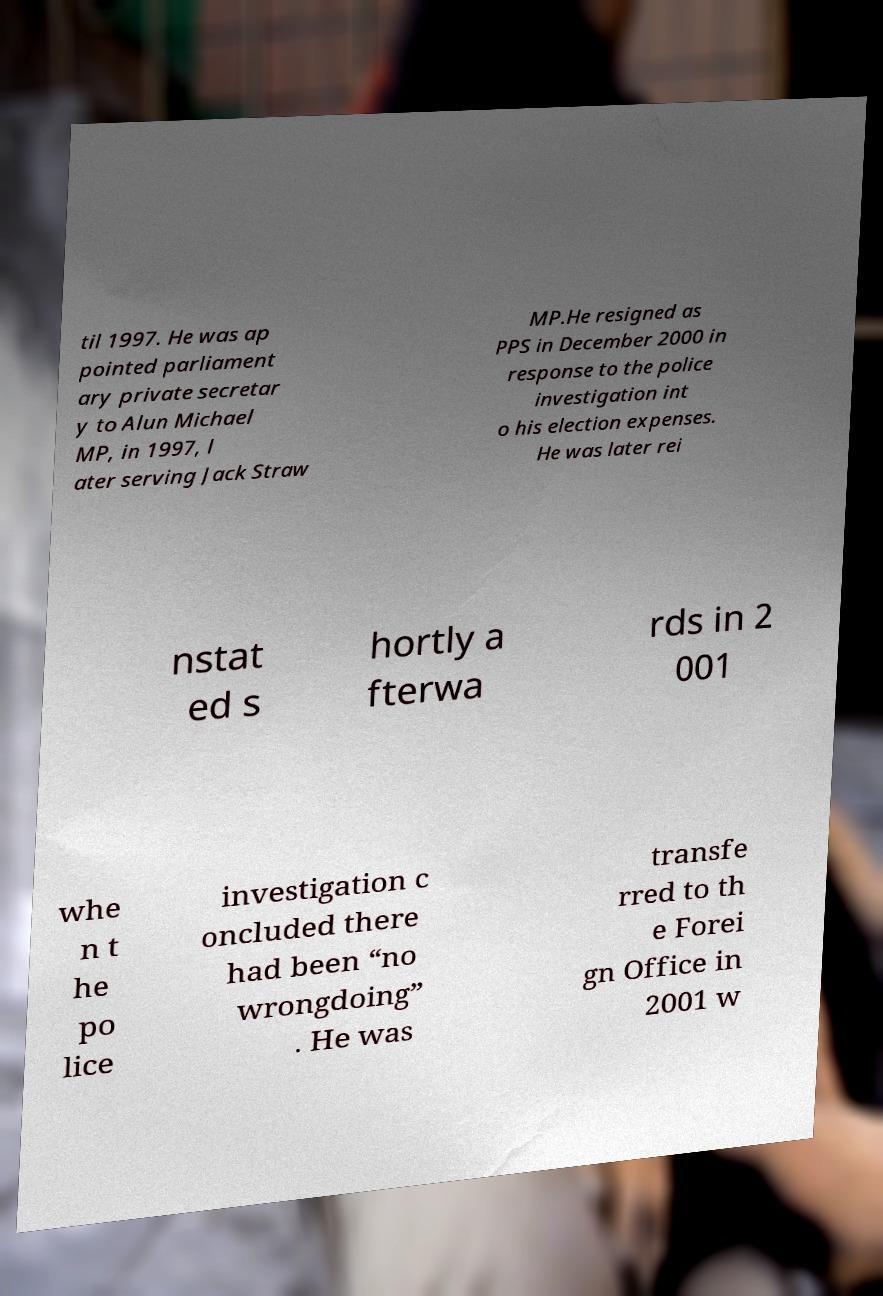What messages or text are displayed in this image? I need them in a readable, typed format. til 1997. He was ap pointed parliament ary private secretar y to Alun Michael MP, in 1997, l ater serving Jack Straw MP.He resigned as PPS in December 2000 in response to the police investigation int o his election expenses. He was later rei nstat ed s hortly a fterwa rds in 2 001 whe n t he po lice investigation c oncluded there had been “no wrongdoing” . He was transfe rred to th e Forei gn Office in 2001 w 